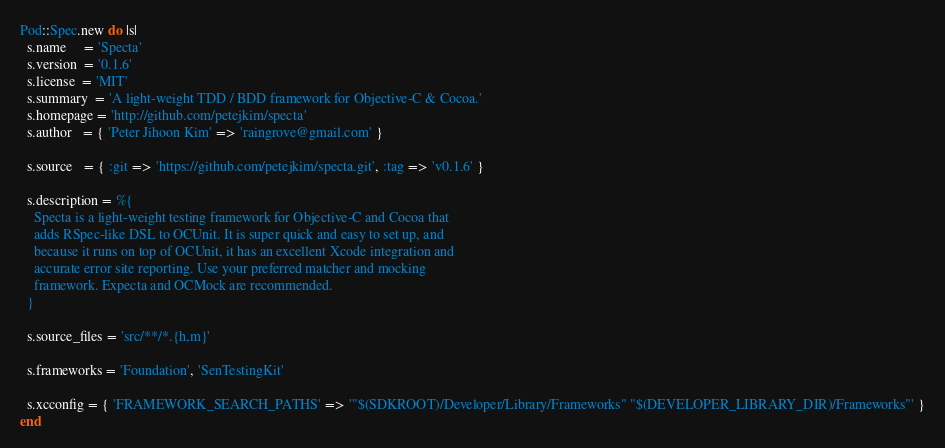Convert code to text. <code><loc_0><loc_0><loc_500><loc_500><_Ruby_>Pod::Spec.new do |s|
  s.name     = 'Specta'
  s.version  = '0.1.6'
  s.license  = 'MIT'
  s.summary  = 'A light-weight TDD / BDD framework for Objective-C & Cocoa.'
  s.homepage = 'http://github.com/petejkim/specta'
  s.author   = { 'Peter Jihoon Kim' => 'raingrove@gmail.com' }

  s.source   = { :git => 'https://github.com/petejkim/specta.git', :tag => 'v0.1.6' }

  s.description = %{
    Specta is a light-weight testing framework for Objective-C and Cocoa that
    adds RSpec-like DSL to OCUnit. It is super quick and easy to set up, and
    because it runs on top of OCUnit, it has an excellent Xcode integration and
    accurate error site reporting. Use your preferred matcher and mocking
    framework. Expecta and OCMock are recommended.
  }

  s.source_files = 'src/**/*.{h,m}'

  s.frameworks = 'Foundation', 'SenTestingKit'

  s.xcconfig = { 'FRAMEWORK_SEARCH_PATHS' => '"$(SDKROOT)/Developer/Library/Frameworks" "$(DEVELOPER_LIBRARY_DIR)/Frameworks"' }
end

</code> 